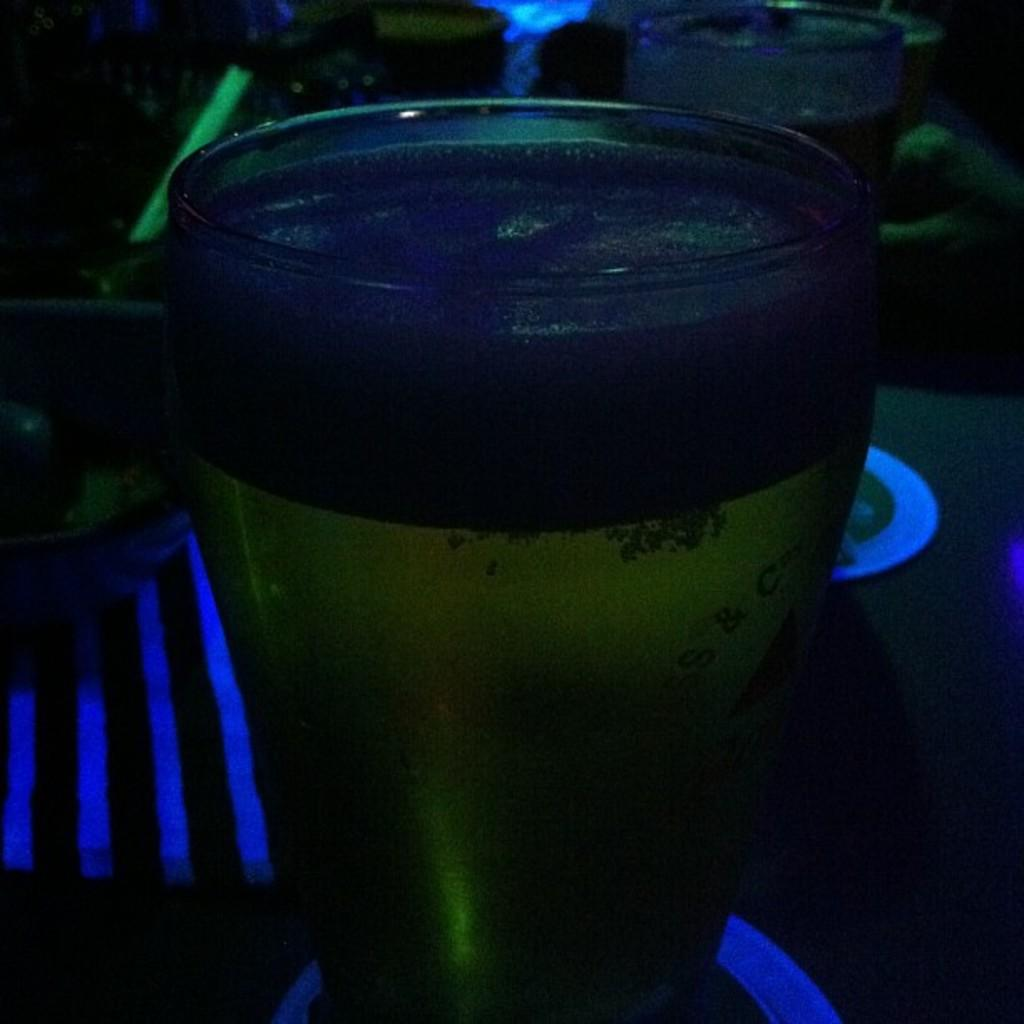What is contained in the glasses in the image? There are glasses with drinks in the image. What else is present on the platform in the image? There is a bowl in the image. Where are the glasses and the bowl located? The glasses and the bowl are placed on a platform. What can be observed about the lighting in the image? The background of the image is dark. What is the opinion of the floor in the image? There is no opinion present in the image, as opinions are subjective and not visible in a photograph. 